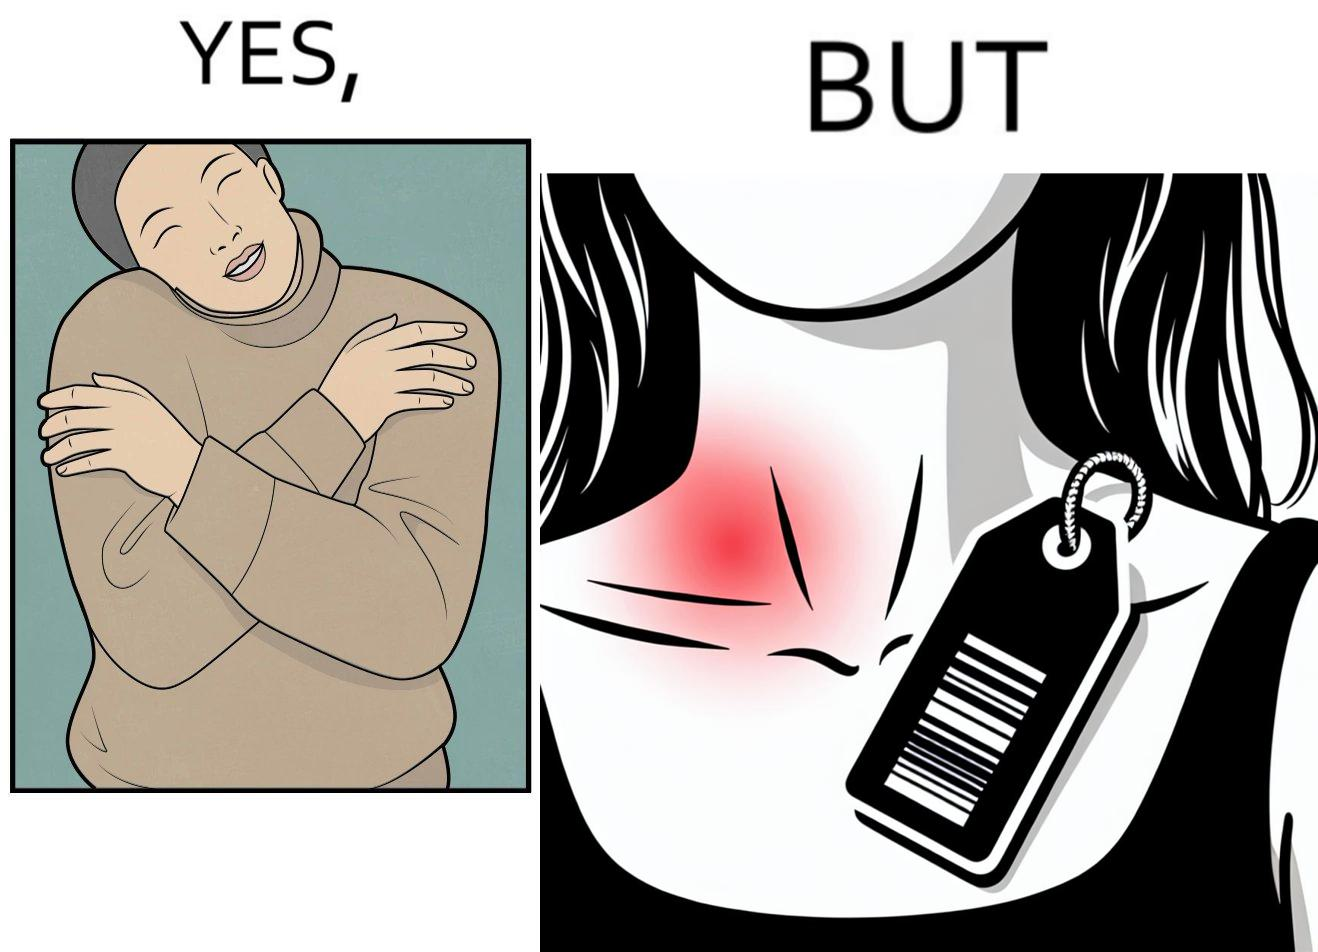Compare the left and right sides of this image. In the left part of the image: It is a woman enjoying the warmth and comfort of her sweater In the right part of the image: It a womans neck, irritated and red due to manufacturers tags on her clothes 